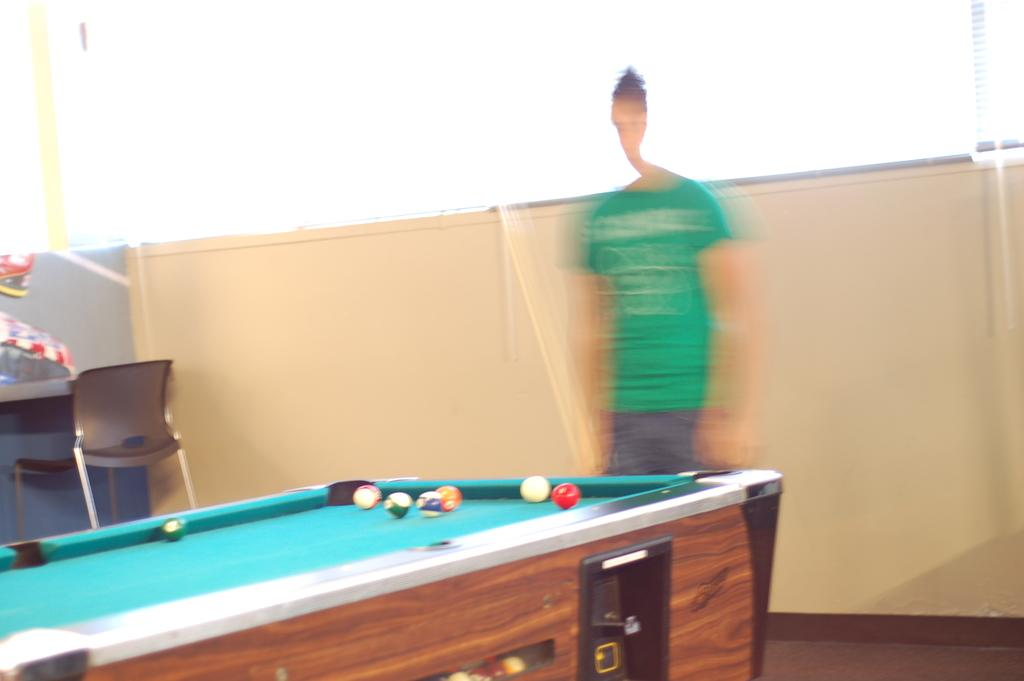What type of furniture is present in the image? There is a table in the image. What color is the table? The table is brown. What objects are on the table? There are balls on the table. What can be seen in the background of the image? There is a wall in the background of the image. What color is the wall? The wall is yellow. Who is present in the background of the image? There is a man standing in the background of the image. What type of chain is hanging from the ceiling in the image? There is no chain hanging from the ceiling in the image. 